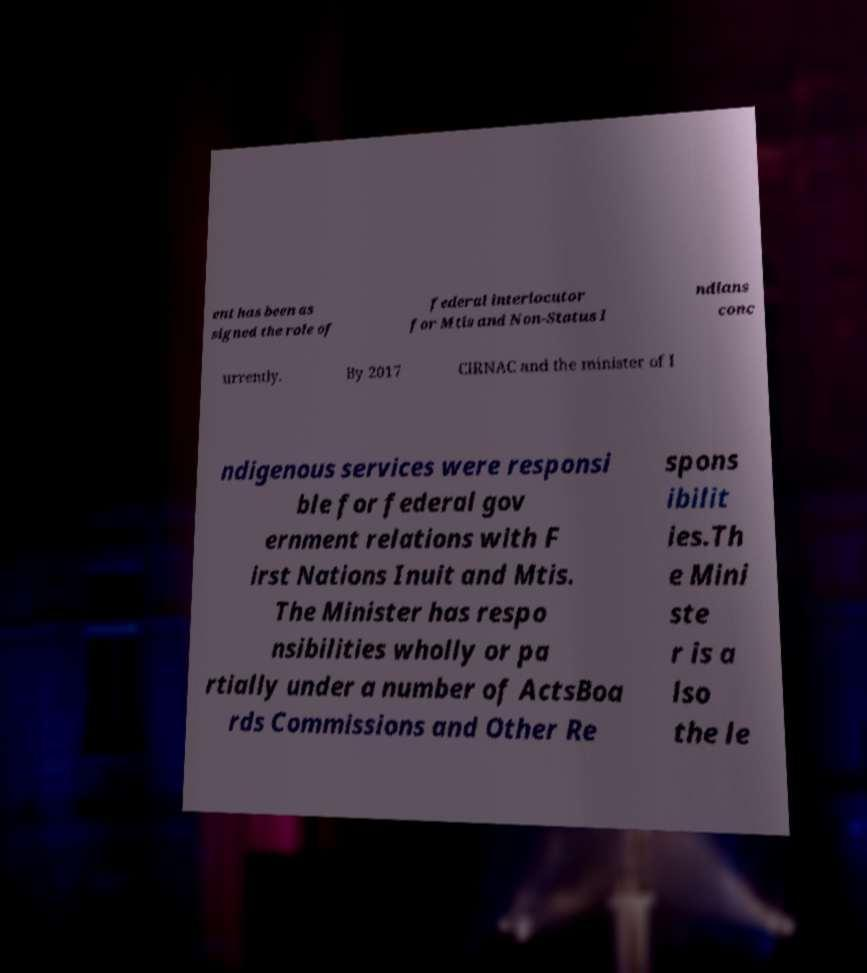Can you read and provide the text displayed in the image?This photo seems to have some interesting text. Can you extract and type it out for me? ent has been as signed the role of federal interlocutor for Mtis and Non-Status I ndians conc urrently. By 2017 CIRNAC and the minister of I ndigenous services were responsi ble for federal gov ernment relations with F irst Nations Inuit and Mtis. The Minister has respo nsibilities wholly or pa rtially under a number of ActsBoa rds Commissions and Other Re spons ibilit ies.Th e Mini ste r is a lso the le 